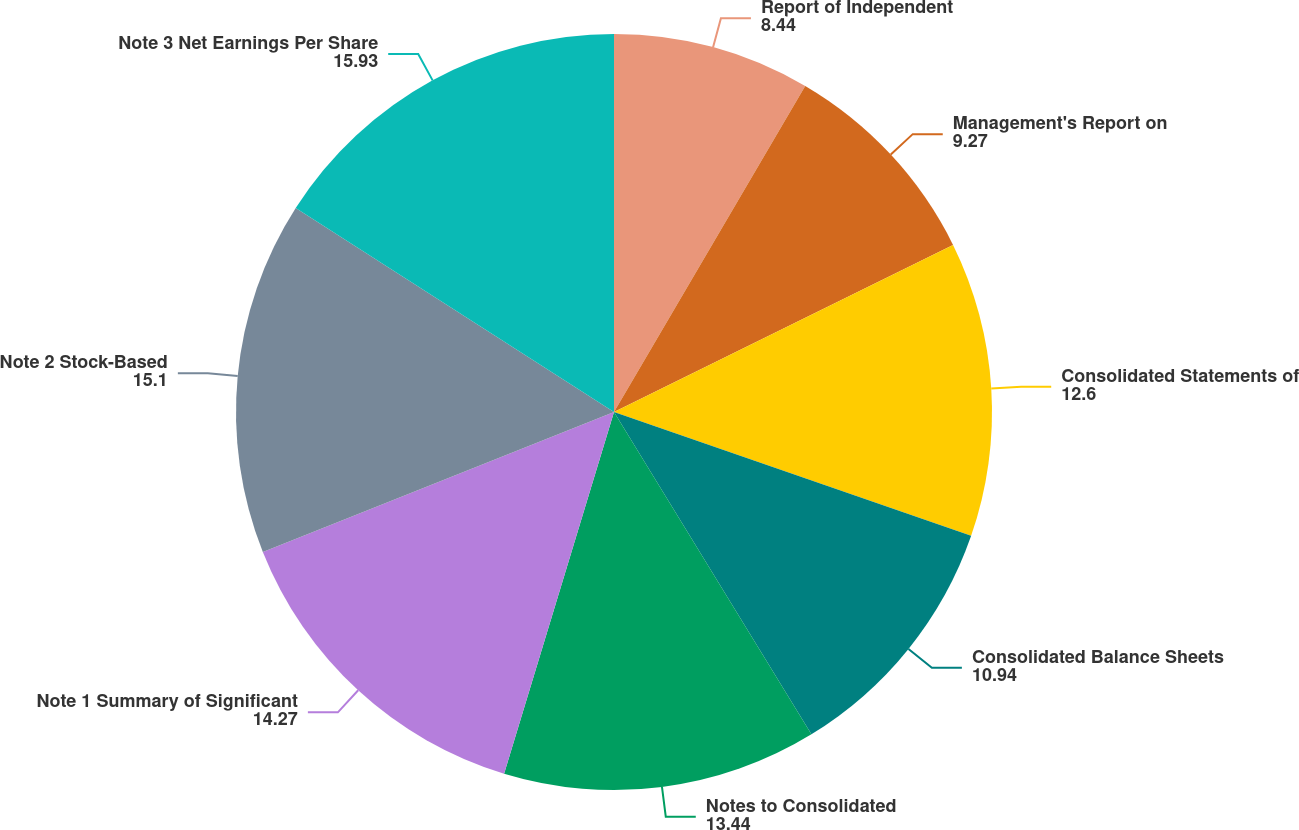Convert chart. <chart><loc_0><loc_0><loc_500><loc_500><pie_chart><fcel>Report of Independent<fcel>Management's Report on<fcel>Consolidated Statements of<fcel>Consolidated Balance Sheets<fcel>Notes to Consolidated<fcel>Note 1 Summary of Significant<fcel>Note 2 Stock-Based<fcel>Note 3 Net Earnings Per Share<nl><fcel>8.44%<fcel>9.27%<fcel>12.6%<fcel>10.94%<fcel>13.44%<fcel>14.27%<fcel>15.1%<fcel>15.93%<nl></chart> 